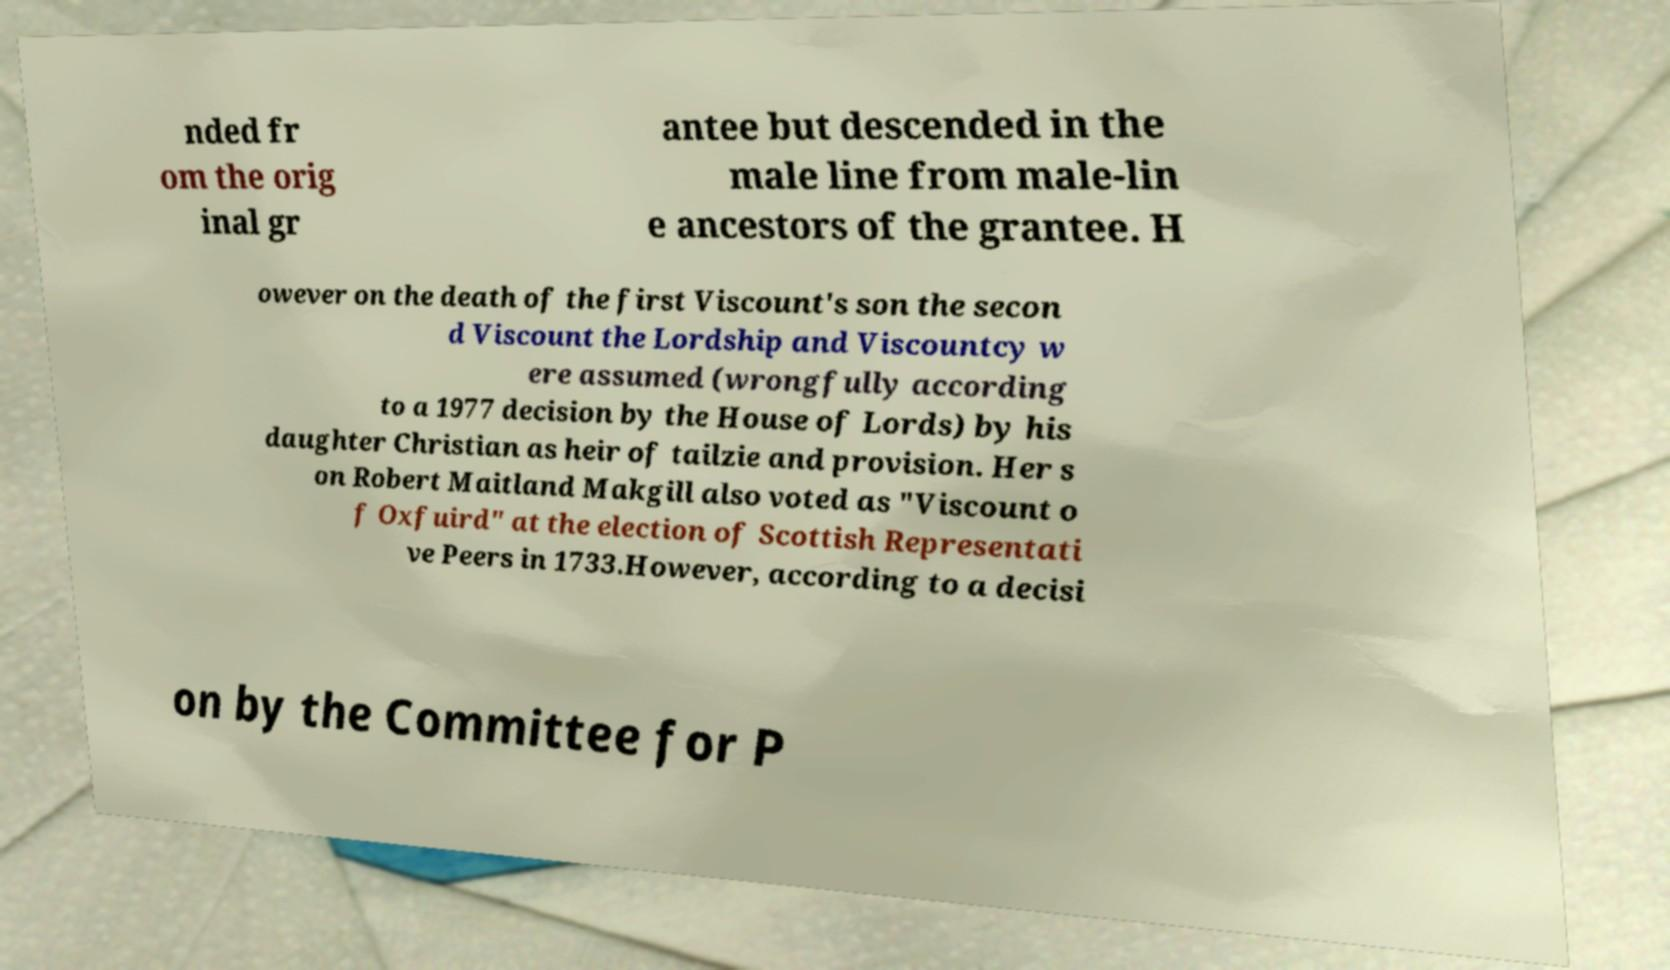For documentation purposes, I need the text within this image transcribed. Could you provide that? nded fr om the orig inal gr antee but descended in the male line from male-lin e ancestors of the grantee. H owever on the death of the first Viscount's son the secon d Viscount the Lordship and Viscountcy w ere assumed (wrongfully according to a 1977 decision by the House of Lords) by his daughter Christian as heir of tailzie and provision. Her s on Robert Maitland Makgill also voted as "Viscount o f Oxfuird" at the election of Scottish Representati ve Peers in 1733.However, according to a decisi on by the Committee for P 